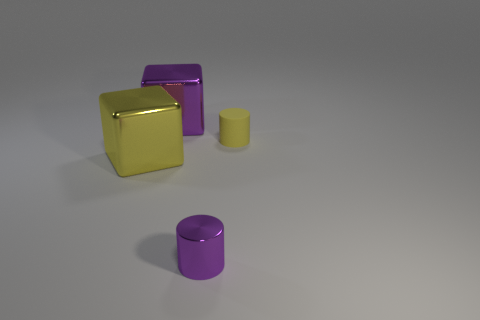Add 4 yellow objects. How many objects exist? 8 Add 2 yellow metal blocks. How many yellow metal blocks exist? 3 Subtract 0 cyan balls. How many objects are left? 4 Subtract all small gray blocks. Subtract all cubes. How many objects are left? 2 Add 4 big yellow blocks. How many big yellow blocks are left? 5 